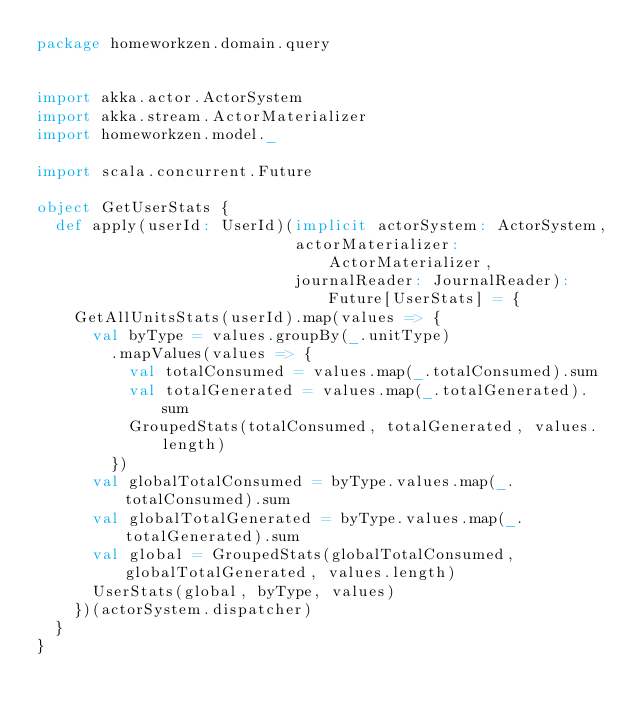<code> <loc_0><loc_0><loc_500><loc_500><_Scala_>package homeworkzen.domain.query


import akka.actor.ActorSystem
import akka.stream.ActorMaterializer
import homeworkzen.model._

import scala.concurrent.Future

object GetUserStats {
  def apply(userId: UserId)(implicit actorSystem: ActorSystem,
                            actorMaterializer: ActorMaterializer,
                            journalReader: JournalReader): Future[UserStats] = {
    GetAllUnitsStats(userId).map(values => {
      val byType = values.groupBy(_.unitType)
        .mapValues(values => {
          val totalConsumed = values.map(_.totalConsumed).sum
          val totalGenerated = values.map(_.totalGenerated).sum
          GroupedStats(totalConsumed, totalGenerated, values.length)
        })
      val globalTotalConsumed = byType.values.map(_.totalConsumed).sum
      val globalTotalGenerated = byType.values.map(_.totalGenerated).sum
      val global = GroupedStats(globalTotalConsumed, globalTotalGenerated, values.length)
      UserStats(global, byType, values)
    })(actorSystem.dispatcher)
  }
}</code> 